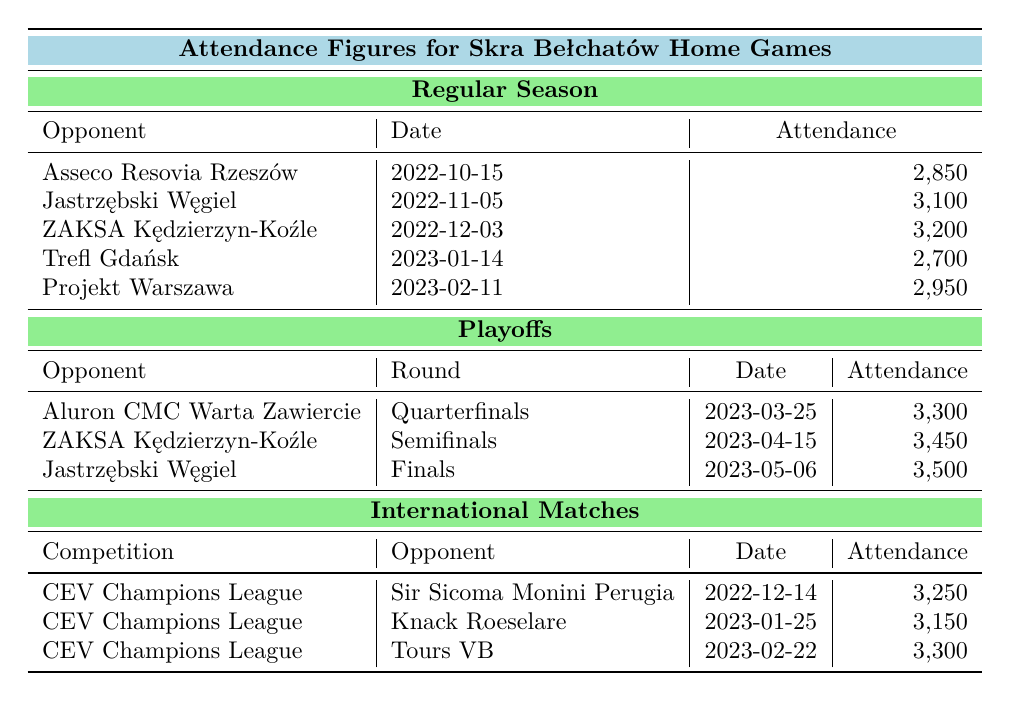What is the highest attendance figure during the regular season? Reviewing the attendance figures for the regular season, the values are 2850, 3100, 3200, 2700, and 2950. The highest among these is 3200, which occurred during the match against ZAKSA Kędzierzyn-Koźle on December 3, 2022.
Answer: 3200 How many people attended the playoffs final match against Jastrzębski Węgiel? The table lists the attendance for the finals match against Jastrzębski Węgiel on May 6, 2023, which shows an attendance of 3500.
Answer: 3500 What is the total attendance for all regular season games? The attendance figures for regular season games are 2850, 3100, 3200, 2700, and 2950. Adding these together gives: 2850 + 3100 + 3200 + 2700 + 2950 = 14800.
Answer: 14800 Which playoff round had the least attendance? The playoff attendance figures are 3300 for the quarterfinals, 3450 for the semifinals, and 3500 for the finals. The least attendance is 3300 in the quarterfinals against Aluron CMC Warta Zawiercie on March 25, 2023.
Answer: Quarterfinals What was the overall average attendance for international matches? For international matches, the attendance figures are 3250, 3150, and 3300. The total is 3250 + 3150 + 3300 = 9700. The average is 9700 / 3 = 3233.33, which rounds to 3233 when considering whole numbers.
Answer: 3233 Did Skra Bełchatów have a higher attendance in playoffs or regular season? The total attendance for playoffs is 3300 + 3450 + 3500 = 10250, while the regular season total is 14800 from earlier calculation. Since 14800 is greater than 10250, the regular season had a higher attendance.
Answer: Yes What is the change in attendance from the regular season match against Trefl Gdańsk to the playoff match against Aluron CMC Warta Zawiercie? The attendance for Trefl Gdańsk is 2700 and for Aluron CMC Warta Zawiercie in the playoffs is 3300. The change is calculated as 3300 - 2700 = 600, indicating an increase of 600 attendees.
Answer: 600 How many matches did Skra Bełchatów play in total across all categories? In the regular season, they played 5 matches, in playoffs 3 matches, and in international matches 3 matches, giving a total of 5 + 3 + 3 = 11 matches.
Answer: 11 Which opponent attracted the highest attendance during international matches? The attendance figures for international matches are 3250, 3150, and 3300. The highest attendance was against Tours VB, which had 3300 attendees on February 22, 2023.
Answer: Tours VB 